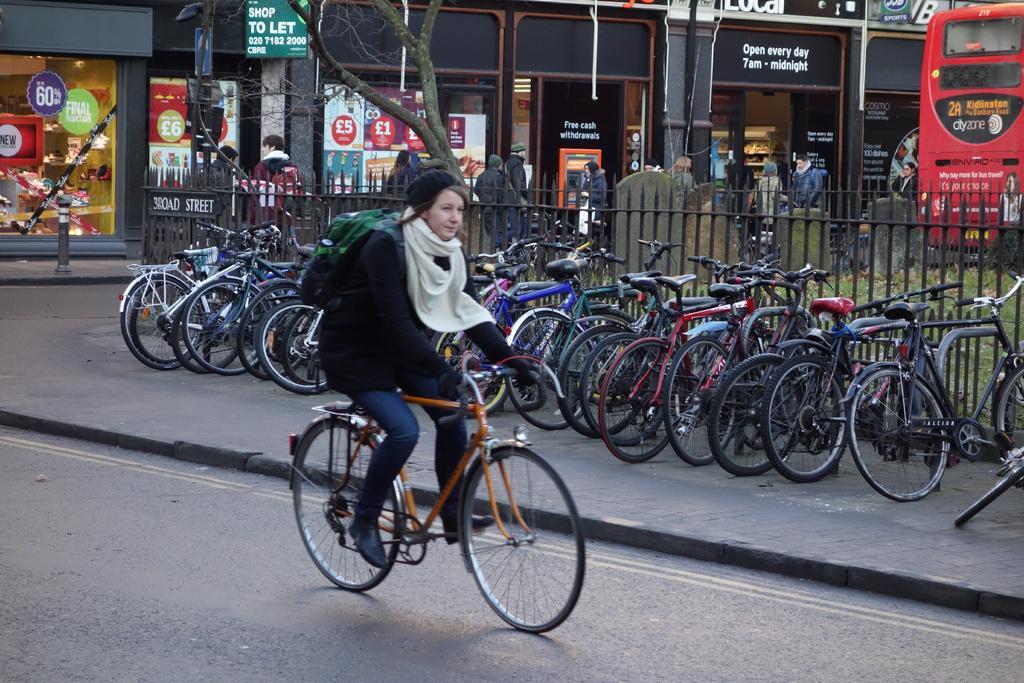Can you describe this image briefly? In the image we can see there is a woman who is sitting on bicycle. On the other side on the footpath there are cycles parked on the road and there are people standing on the road. 